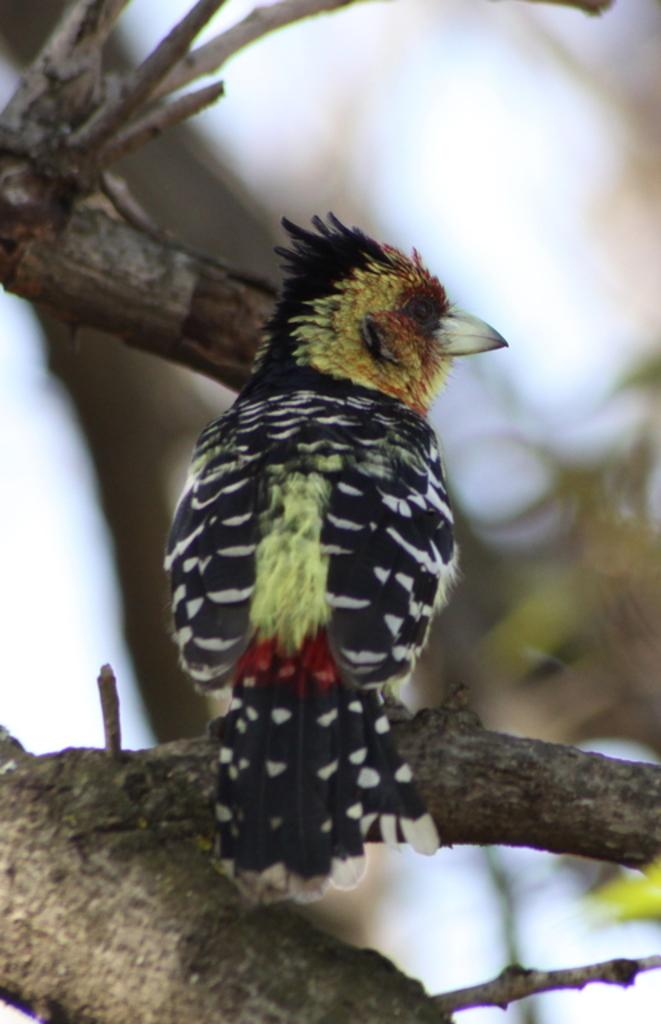What type of animal can be seen in the image? There is a bird in the image. Where is the bird located? The bird is standing on a branch of a tree. Can you describe the background of the image? The background of the image is blurred. What type of lipstick is the bird wearing in the image? There is no lipstick or any indication of makeup on the bird in the image. 